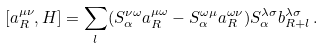<formula> <loc_0><loc_0><loc_500><loc_500>[ a ^ { \mu \nu } _ { R } , H ] = \sum _ { l } ( S _ { \alpha } ^ { \nu \omega } a ^ { \mu \omega } _ { R } - S _ { \alpha } ^ { \omega \mu } a ^ { \omega \nu } _ { R } ) S _ { \alpha } ^ { \lambda \sigma } b ^ { \lambda \sigma } _ { { R } + { l } } \, .</formula> 